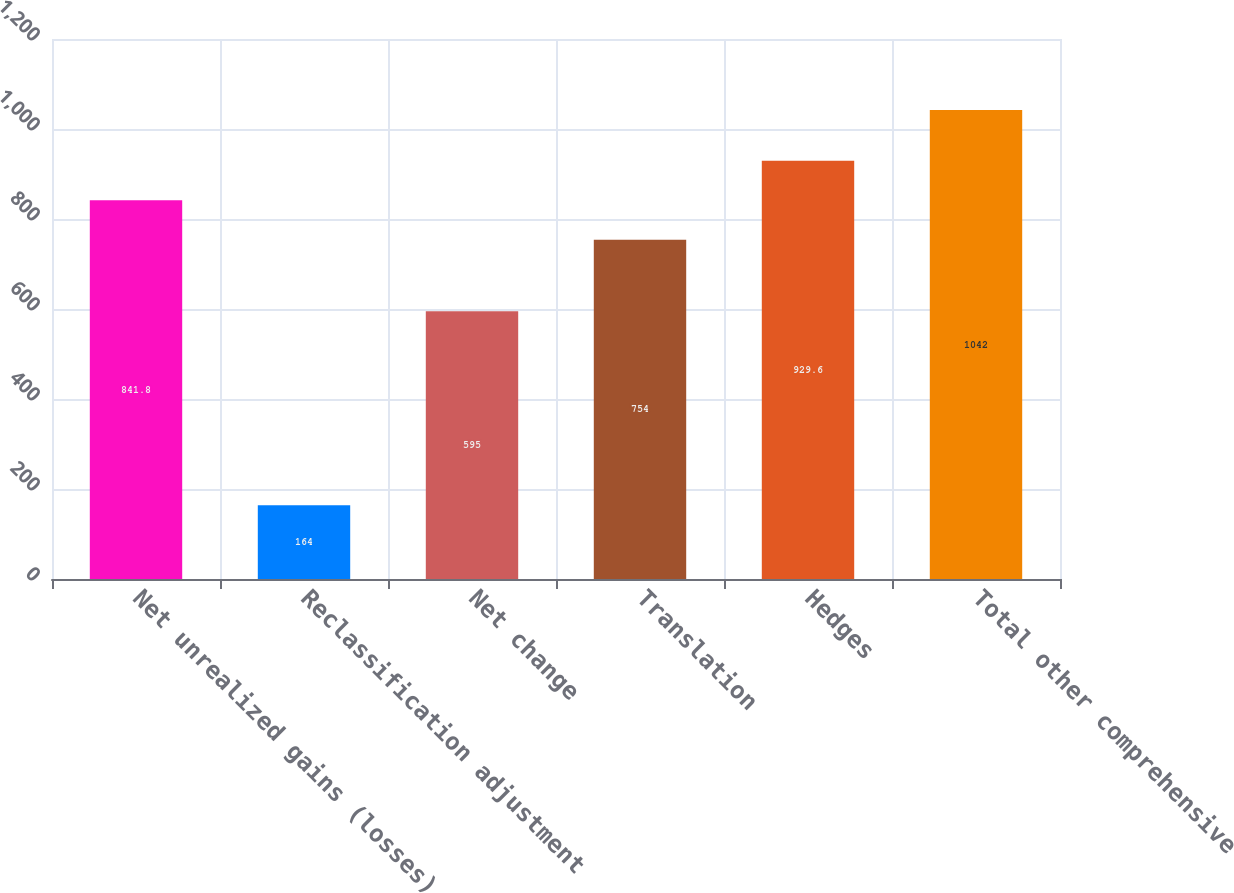Convert chart to OTSL. <chart><loc_0><loc_0><loc_500><loc_500><bar_chart><fcel>Net unrealized gains (losses)<fcel>Reclassification adjustment<fcel>Net change<fcel>Translation<fcel>Hedges<fcel>Total other comprehensive<nl><fcel>841.8<fcel>164<fcel>595<fcel>754<fcel>929.6<fcel>1042<nl></chart> 